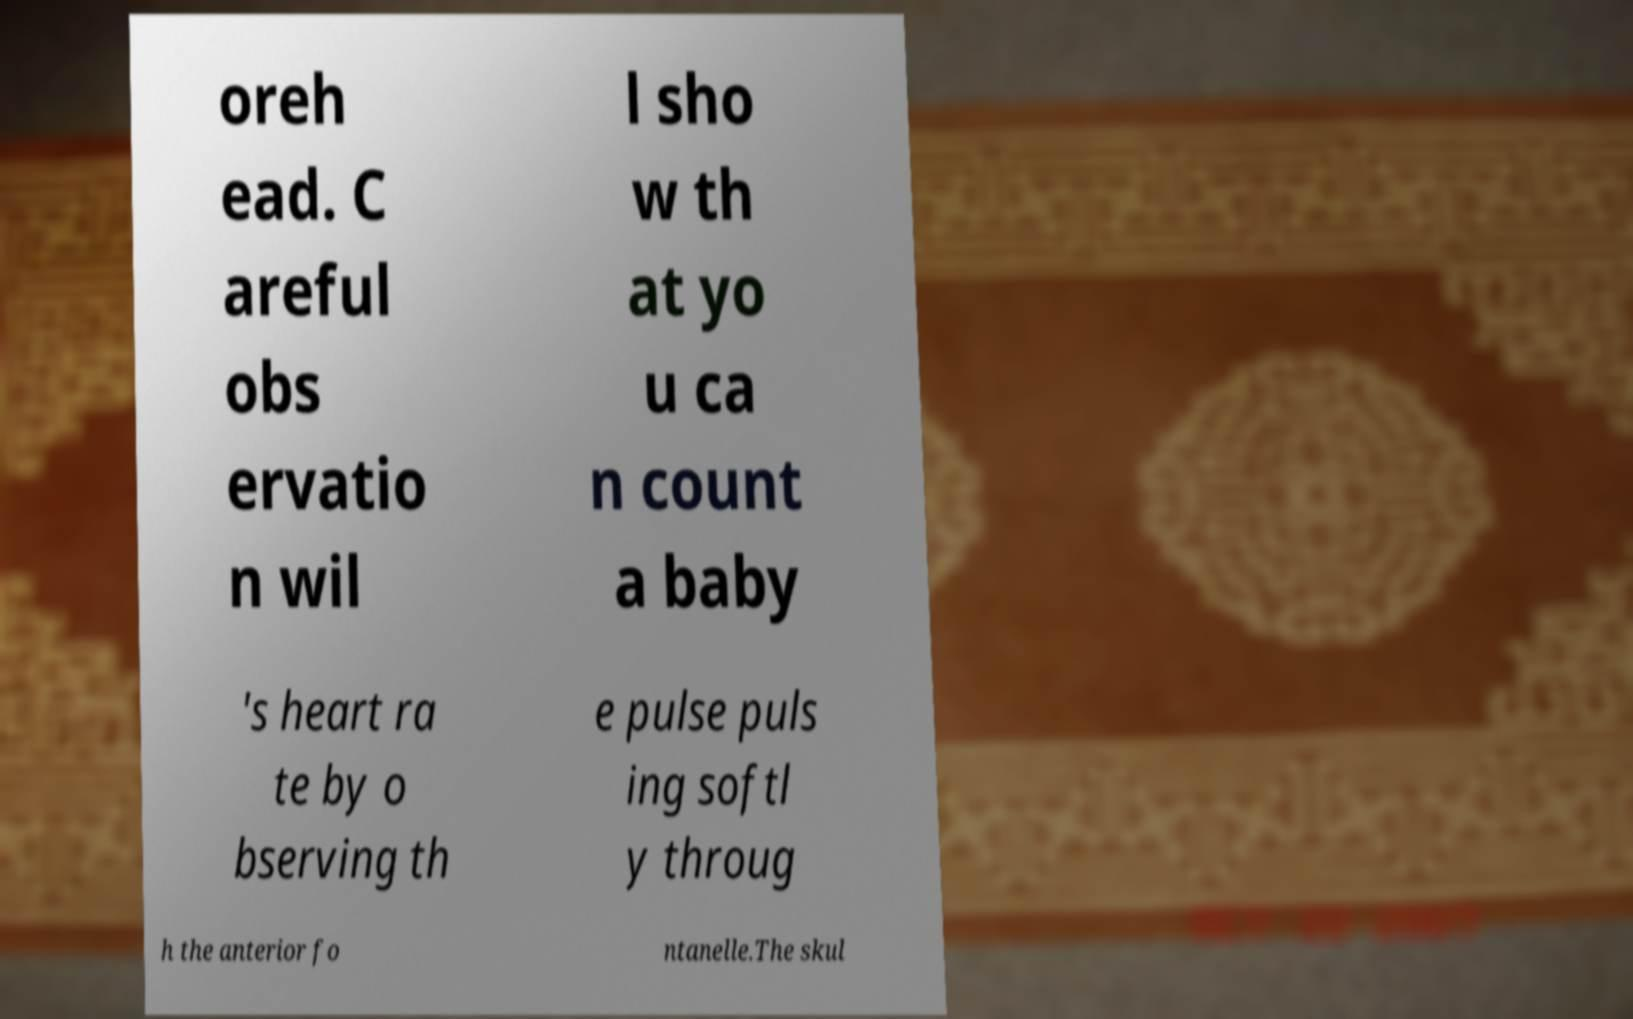Could you extract and type out the text from this image? oreh ead. C areful obs ervatio n wil l sho w th at yo u ca n count a baby 's heart ra te by o bserving th e pulse puls ing softl y throug h the anterior fo ntanelle.The skul 